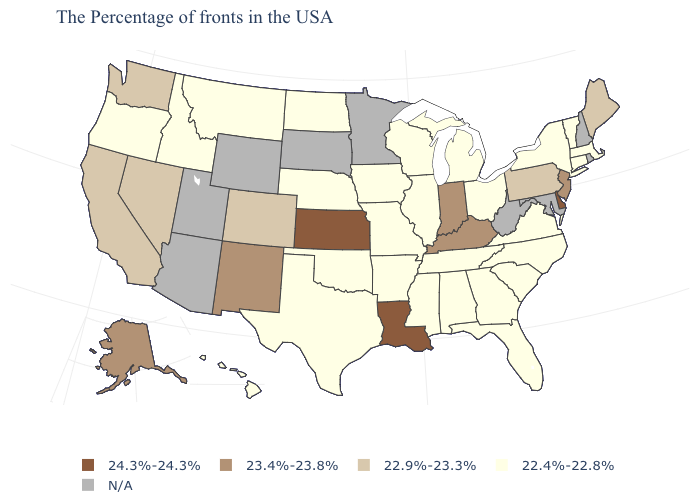Does South Carolina have the lowest value in the USA?
Short answer required. Yes. Name the states that have a value in the range 22.4%-22.8%?
Be succinct. Massachusetts, Vermont, Connecticut, New York, Virginia, North Carolina, South Carolina, Ohio, Florida, Georgia, Michigan, Alabama, Tennessee, Wisconsin, Illinois, Mississippi, Missouri, Arkansas, Iowa, Nebraska, Oklahoma, Texas, North Dakota, Montana, Idaho, Oregon, Hawaii. Name the states that have a value in the range 22.9%-23.3%?
Write a very short answer. Maine, Pennsylvania, Colorado, Nevada, California, Washington. Is the legend a continuous bar?
Be succinct. No. What is the value of Mississippi?
Write a very short answer. 22.4%-22.8%. What is the value of New York?
Write a very short answer. 22.4%-22.8%. What is the lowest value in the USA?
Quick response, please. 22.4%-22.8%. Which states have the lowest value in the USA?
Keep it brief. Massachusetts, Vermont, Connecticut, New York, Virginia, North Carolina, South Carolina, Ohio, Florida, Georgia, Michigan, Alabama, Tennessee, Wisconsin, Illinois, Mississippi, Missouri, Arkansas, Iowa, Nebraska, Oklahoma, Texas, North Dakota, Montana, Idaho, Oregon, Hawaii. What is the lowest value in the USA?
Be succinct. 22.4%-22.8%. What is the value of Washington?
Give a very brief answer. 22.9%-23.3%. Which states have the highest value in the USA?
Concise answer only. Delaware, Louisiana, Kansas. Is the legend a continuous bar?
Be succinct. No. What is the value of West Virginia?
Concise answer only. N/A. Name the states that have a value in the range 23.4%-23.8%?
Concise answer only. New Jersey, Kentucky, Indiana, New Mexico, Alaska. 